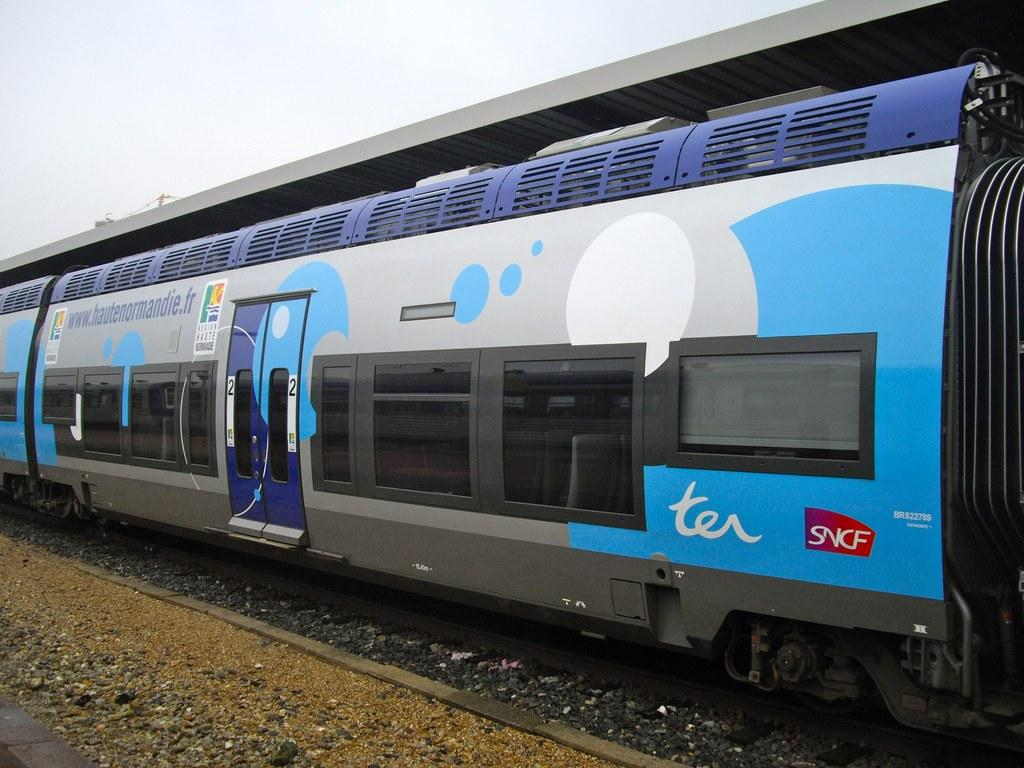What is the main subject of the image? The main subject of the image is a train. What features can be observed on the train? The train has doors and windows. Are there any additional details on the train? Yes, there are posters on the train. What is the train's position in the image? The train is on a track. What can be seen at the bottom of the image? There is ground at the bottom of the image. What is visible at the top of the image? The sky is visible at the top of the image. What can be seen through the train windows? Seats are visible through the windows. How many pizzas are being carried by the wing of the train in the image? There is no wing on the train in the image, and therefore no pizzas can be carried by it. What type of arm is visible on the train in the image? There is no arm visible on the train in the image. 